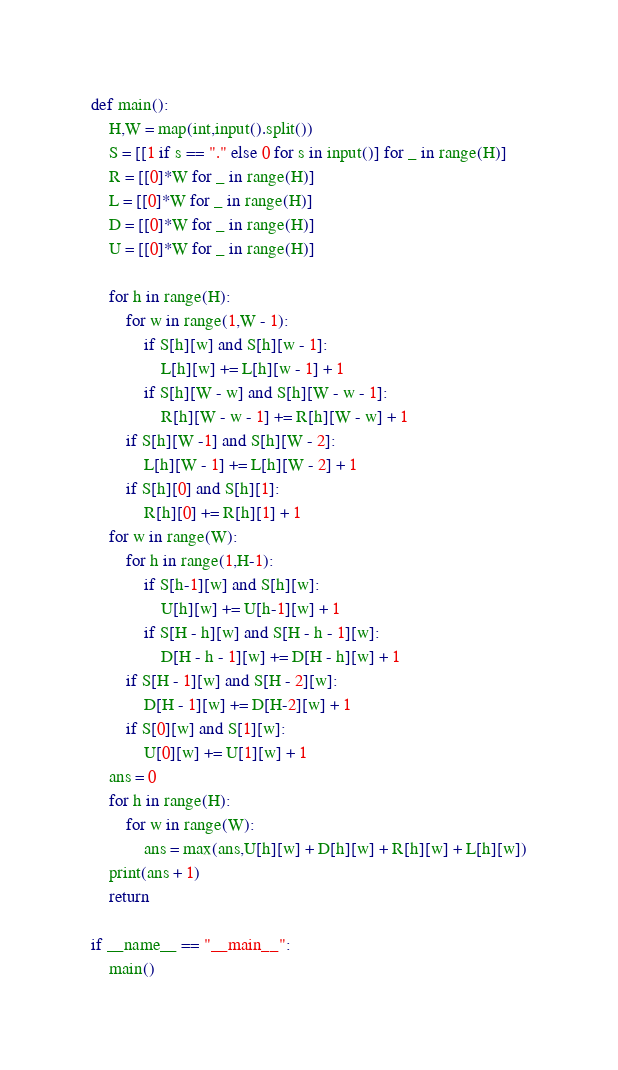Convert code to text. <code><loc_0><loc_0><loc_500><loc_500><_Python_>def main():
    H,W = map(int,input().split())
    S = [[1 if s == "." else 0 for s in input()] for _ in range(H)]
    R = [[0]*W for _ in range(H)]
    L = [[0]*W for _ in range(H)]
    D = [[0]*W for _ in range(H)]
    U = [[0]*W for _ in range(H)]

    for h in range(H):
        for w in range(1,W - 1):
            if S[h][w] and S[h][w - 1]:
                L[h][w] += L[h][w - 1] + 1
            if S[h][W - w] and S[h][W - w - 1]:
                R[h][W - w - 1] += R[h][W - w] + 1
        if S[h][W -1] and S[h][W - 2]:
            L[h][W - 1] += L[h][W - 2] + 1
        if S[h][0] and S[h][1]:
            R[h][0] += R[h][1] + 1
    for w in range(W):
        for h in range(1,H-1):
            if S[h-1][w] and S[h][w]:
                U[h][w] += U[h-1][w] + 1
            if S[H - h][w] and S[H - h - 1][w]:
                D[H - h - 1][w] += D[H - h][w] + 1
        if S[H - 1][w] and S[H - 2][w]:
            D[H - 1][w] += D[H-2][w] + 1
        if S[0][w] and S[1][w]:
            U[0][w] += U[1][w] + 1
    ans = 0
    for h in range(H):
        for w in range(W):
            ans = max(ans,U[h][w] + D[h][w] + R[h][w] + L[h][w])
    print(ans + 1)
    return 

if __name__ == "__main__":
    main()</code> 